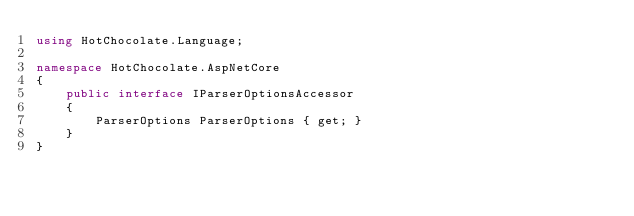Convert code to text. <code><loc_0><loc_0><loc_500><loc_500><_C#_>using HotChocolate.Language;

namespace HotChocolate.AspNetCore
{
    public interface IParserOptionsAccessor
    {
        ParserOptions ParserOptions { get; }
    }
}
</code> 